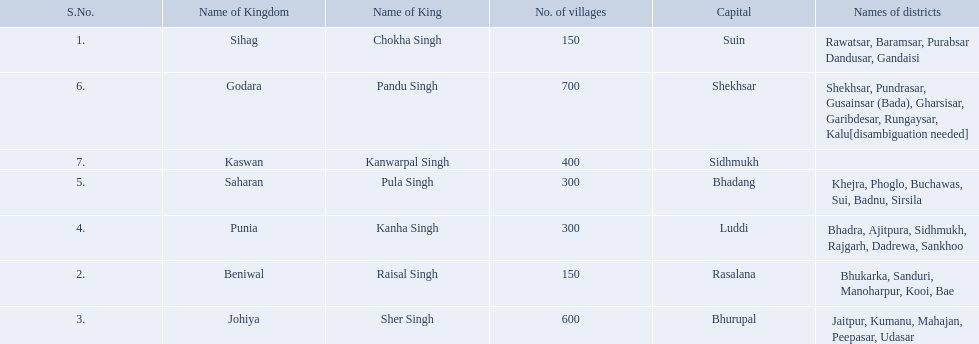What are all of the kingdoms? Sihag, Beniwal, Johiya, Punia, Saharan, Godara, Kaswan. How many villages do they contain? 150, 150, 600, 300, 300, 700, 400. How many are in godara? 700. Which kingdom comes next in highest amount of villages? Johiya. 